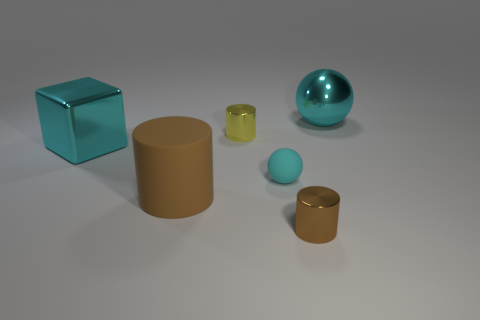Add 3 small yellow metal cylinders. How many objects exist? 9 Subtract all cubes. How many objects are left? 5 Add 2 large purple rubber balls. How many large purple rubber balls exist? 2 Subtract 0 green spheres. How many objects are left? 6 Subtract all cyan matte objects. Subtract all large rubber cylinders. How many objects are left? 4 Add 5 cyan rubber balls. How many cyan rubber balls are left? 6 